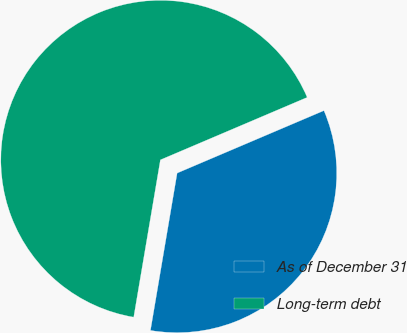Convert chart to OTSL. <chart><loc_0><loc_0><loc_500><loc_500><pie_chart><fcel>As of December 31<fcel>Long-term debt<nl><fcel>34.08%<fcel>65.92%<nl></chart> 